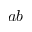<formula> <loc_0><loc_0><loc_500><loc_500>a b</formula> 